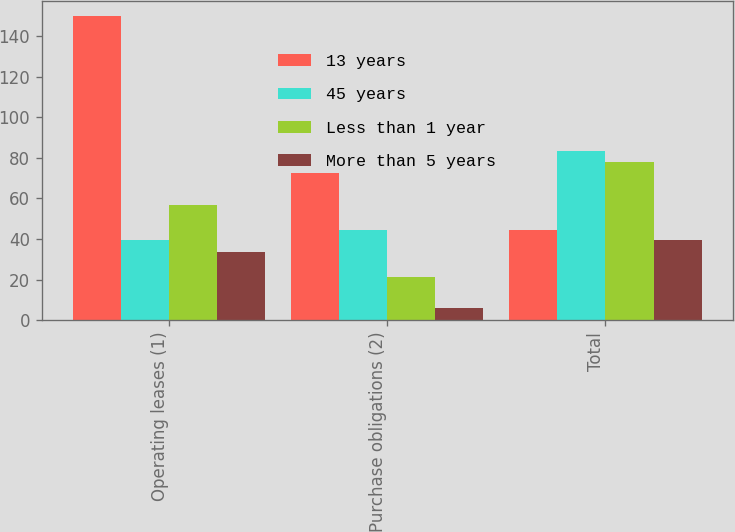Convert chart. <chart><loc_0><loc_0><loc_500><loc_500><stacked_bar_chart><ecel><fcel>Operating leases (1)<fcel>Purchase obligations (2)<fcel>Total<nl><fcel>13 years<fcel>150<fcel>72.4<fcel>44.2<nl><fcel>45 years<fcel>39.4<fcel>44.2<fcel>83.6<nl><fcel>Less than 1 year<fcel>56.6<fcel>21.3<fcel>77.9<nl><fcel>More than 5 years<fcel>33.5<fcel>5.8<fcel>39.3<nl></chart> 